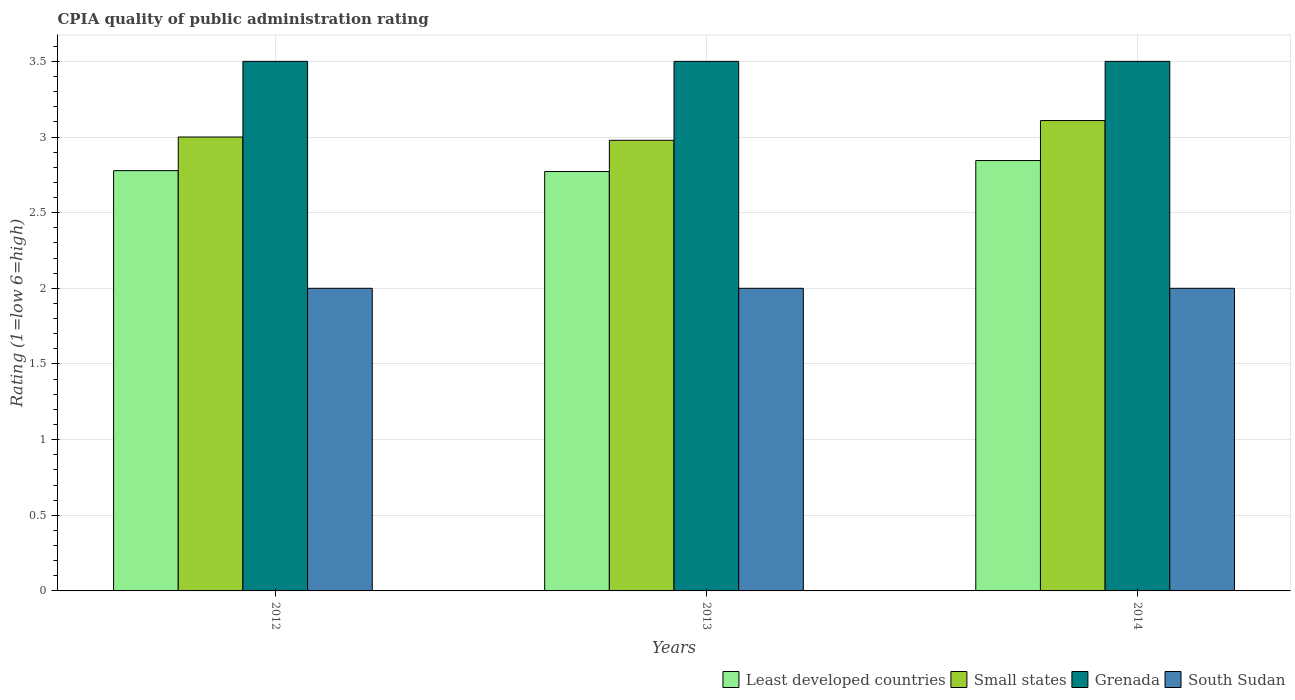How many different coloured bars are there?
Give a very brief answer. 4. How many groups of bars are there?
Offer a terse response. 3. Are the number of bars on each tick of the X-axis equal?
Your response must be concise. Yes. How many bars are there on the 3rd tick from the left?
Offer a very short reply. 4. How many bars are there on the 3rd tick from the right?
Make the answer very short. 4. What is the label of the 3rd group of bars from the left?
Your answer should be compact. 2014. What is the CPIA rating in Least developed countries in 2013?
Offer a very short reply. 2.77. In which year was the CPIA rating in Small states maximum?
Offer a terse response. 2014. What is the total CPIA rating in Least developed countries in the graph?
Offer a very short reply. 8.39. What is the difference between the CPIA rating in South Sudan in 2012 and that in 2014?
Your answer should be very brief. 0. What is the difference between the CPIA rating in Small states in 2014 and the CPIA rating in Grenada in 2013?
Provide a short and direct response. -0.39. What is the average CPIA rating in Least developed countries per year?
Provide a succinct answer. 2.8. In the year 2012, what is the difference between the CPIA rating in Least developed countries and CPIA rating in Grenada?
Offer a very short reply. -0.72. In how many years, is the CPIA rating in Grenada greater than 0.1?
Your response must be concise. 3. What is the ratio of the CPIA rating in South Sudan in 2012 to that in 2013?
Offer a terse response. 1. Is the difference between the CPIA rating in Least developed countries in 2012 and 2013 greater than the difference between the CPIA rating in Grenada in 2012 and 2013?
Your answer should be compact. Yes. What is the difference between the highest and the second highest CPIA rating in South Sudan?
Offer a very short reply. 0. What is the difference between the highest and the lowest CPIA rating in Small states?
Provide a short and direct response. 0.13. In how many years, is the CPIA rating in South Sudan greater than the average CPIA rating in South Sudan taken over all years?
Your response must be concise. 0. What does the 3rd bar from the left in 2014 represents?
Your response must be concise. Grenada. What does the 3rd bar from the right in 2013 represents?
Give a very brief answer. Small states. How many bars are there?
Provide a succinct answer. 12. Does the graph contain any zero values?
Give a very brief answer. No. Where does the legend appear in the graph?
Your response must be concise. Bottom right. How are the legend labels stacked?
Provide a short and direct response. Horizontal. What is the title of the graph?
Your response must be concise. CPIA quality of public administration rating. Does "Sudan" appear as one of the legend labels in the graph?
Keep it short and to the point. No. What is the label or title of the X-axis?
Provide a succinct answer. Years. What is the label or title of the Y-axis?
Give a very brief answer. Rating (1=low 6=high). What is the Rating (1=low 6=high) in Least developed countries in 2012?
Your answer should be compact. 2.78. What is the Rating (1=low 6=high) in South Sudan in 2012?
Your response must be concise. 2. What is the Rating (1=low 6=high) in Least developed countries in 2013?
Ensure brevity in your answer.  2.77. What is the Rating (1=low 6=high) of Small states in 2013?
Offer a terse response. 2.98. What is the Rating (1=low 6=high) in Grenada in 2013?
Provide a succinct answer. 3.5. What is the Rating (1=low 6=high) in Least developed countries in 2014?
Your answer should be compact. 2.84. What is the Rating (1=low 6=high) of Small states in 2014?
Make the answer very short. 3.11. What is the Rating (1=low 6=high) in Grenada in 2014?
Your response must be concise. 3.5. Across all years, what is the maximum Rating (1=low 6=high) of Least developed countries?
Make the answer very short. 2.84. Across all years, what is the maximum Rating (1=low 6=high) in Small states?
Ensure brevity in your answer.  3.11. Across all years, what is the minimum Rating (1=low 6=high) of Least developed countries?
Ensure brevity in your answer.  2.77. Across all years, what is the minimum Rating (1=low 6=high) of Small states?
Make the answer very short. 2.98. Across all years, what is the minimum Rating (1=low 6=high) of Grenada?
Provide a short and direct response. 3.5. What is the total Rating (1=low 6=high) of Least developed countries in the graph?
Offer a terse response. 8.39. What is the total Rating (1=low 6=high) in Small states in the graph?
Provide a short and direct response. 9.09. What is the difference between the Rating (1=low 6=high) in Least developed countries in 2012 and that in 2013?
Provide a short and direct response. 0.01. What is the difference between the Rating (1=low 6=high) in Small states in 2012 and that in 2013?
Make the answer very short. 0.02. What is the difference between the Rating (1=low 6=high) of Least developed countries in 2012 and that in 2014?
Your answer should be very brief. -0.07. What is the difference between the Rating (1=low 6=high) of Small states in 2012 and that in 2014?
Offer a very short reply. -0.11. What is the difference between the Rating (1=low 6=high) in Least developed countries in 2013 and that in 2014?
Provide a short and direct response. -0.07. What is the difference between the Rating (1=low 6=high) in Small states in 2013 and that in 2014?
Keep it short and to the point. -0.13. What is the difference between the Rating (1=low 6=high) of South Sudan in 2013 and that in 2014?
Offer a very short reply. 0. What is the difference between the Rating (1=low 6=high) of Least developed countries in 2012 and the Rating (1=low 6=high) of Small states in 2013?
Your answer should be very brief. -0.2. What is the difference between the Rating (1=low 6=high) of Least developed countries in 2012 and the Rating (1=low 6=high) of Grenada in 2013?
Your answer should be compact. -0.72. What is the difference between the Rating (1=low 6=high) in Grenada in 2012 and the Rating (1=low 6=high) in South Sudan in 2013?
Give a very brief answer. 1.5. What is the difference between the Rating (1=low 6=high) of Least developed countries in 2012 and the Rating (1=low 6=high) of Small states in 2014?
Keep it short and to the point. -0.33. What is the difference between the Rating (1=low 6=high) in Least developed countries in 2012 and the Rating (1=low 6=high) in Grenada in 2014?
Ensure brevity in your answer.  -0.72. What is the difference between the Rating (1=low 6=high) of Small states in 2012 and the Rating (1=low 6=high) of South Sudan in 2014?
Your answer should be compact. 1. What is the difference between the Rating (1=low 6=high) in Grenada in 2012 and the Rating (1=low 6=high) in South Sudan in 2014?
Offer a terse response. 1.5. What is the difference between the Rating (1=low 6=high) of Least developed countries in 2013 and the Rating (1=low 6=high) of Small states in 2014?
Give a very brief answer. -0.34. What is the difference between the Rating (1=low 6=high) of Least developed countries in 2013 and the Rating (1=low 6=high) of Grenada in 2014?
Offer a very short reply. -0.73. What is the difference between the Rating (1=low 6=high) in Least developed countries in 2013 and the Rating (1=low 6=high) in South Sudan in 2014?
Your response must be concise. 0.77. What is the difference between the Rating (1=low 6=high) in Small states in 2013 and the Rating (1=low 6=high) in Grenada in 2014?
Offer a very short reply. -0.52. What is the difference between the Rating (1=low 6=high) in Small states in 2013 and the Rating (1=low 6=high) in South Sudan in 2014?
Give a very brief answer. 0.98. What is the average Rating (1=low 6=high) in Least developed countries per year?
Ensure brevity in your answer.  2.8. What is the average Rating (1=low 6=high) of Small states per year?
Offer a very short reply. 3.03. In the year 2012, what is the difference between the Rating (1=low 6=high) in Least developed countries and Rating (1=low 6=high) in Small states?
Offer a terse response. -0.22. In the year 2012, what is the difference between the Rating (1=low 6=high) of Least developed countries and Rating (1=low 6=high) of Grenada?
Provide a succinct answer. -0.72. In the year 2012, what is the difference between the Rating (1=low 6=high) in Grenada and Rating (1=low 6=high) in South Sudan?
Your answer should be very brief. 1.5. In the year 2013, what is the difference between the Rating (1=low 6=high) of Least developed countries and Rating (1=low 6=high) of Small states?
Provide a short and direct response. -0.21. In the year 2013, what is the difference between the Rating (1=low 6=high) of Least developed countries and Rating (1=low 6=high) of Grenada?
Your answer should be compact. -0.73. In the year 2013, what is the difference between the Rating (1=low 6=high) in Least developed countries and Rating (1=low 6=high) in South Sudan?
Offer a terse response. 0.77. In the year 2013, what is the difference between the Rating (1=low 6=high) of Small states and Rating (1=low 6=high) of Grenada?
Keep it short and to the point. -0.52. In the year 2013, what is the difference between the Rating (1=low 6=high) of Small states and Rating (1=low 6=high) of South Sudan?
Your response must be concise. 0.98. In the year 2013, what is the difference between the Rating (1=low 6=high) in Grenada and Rating (1=low 6=high) in South Sudan?
Offer a terse response. 1.5. In the year 2014, what is the difference between the Rating (1=low 6=high) of Least developed countries and Rating (1=low 6=high) of Small states?
Your answer should be very brief. -0.26. In the year 2014, what is the difference between the Rating (1=low 6=high) of Least developed countries and Rating (1=low 6=high) of Grenada?
Give a very brief answer. -0.66. In the year 2014, what is the difference between the Rating (1=low 6=high) of Least developed countries and Rating (1=low 6=high) of South Sudan?
Your response must be concise. 0.84. In the year 2014, what is the difference between the Rating (1=low 6=high) in Small states and Rating (1=low 6=high) in Grenada?
Make the answer very short. -0.39. In the year 2014, what is the difference between the Rating (1=low 6=high) in Small states and Rating (1=low 6=high) in South Sudan?
Your response must be concise. 1.11. In the year 2014, what is the difference between the Rating (1=low 6=high) of Grenada and Rating (1=low 6=high) of South Sudan?
Your answer should be compact. 1.5. What is the ratio of the Rating (1=low 6=high) of Least developed countries in 2012 to that in 2013?
Keep it short and to the point. 1. What is the ratio of the Rating (1=low 6=high) of Small states in 2012 to that in 2013?
Provide a short and direct response. 1.01. What is the ratio of the Rating (1=low 6=high) in Grenada in 2012 to that in 2013?
Make the answer very short. 1. What is the ratio of the Rating (1=low 6=high) in South Sudan in 2012 to that in 2013?
Offer a very short reply. 1. What is the ratio of the Rating (1=low 6=high) in Least developed countries in 2012 to that in 2014?
Keep it short and to the point. 0.98. What is the ratio of the Rating (1=low 6=high) of South Sudan in 2012 to that in 2014?
Offer a terse response. 1. What is the ratio of the Rating (1=low 6=high) of Least developed countries in 2013 to that in 2014?
Your answer should be very brief. 0.97. What is the ratio of the Rating (1=low 6=high) of Small states in 2013 to that in 2014?
Ensure brevity in your answer.  0.96. What is the ratio of the Rating (1=low 6=high) of South Sudan in 2013 to that in 2014?
Your answer should be compact. 1. What is the difference between the highest and the second highest Rating (1=low 6=high) in Least developed countries?
Give a very brief answer. 0.07. What is the difference between the highest and the second highest Rating (1=low 6=high) in Small states?
Your answer should be compact. 0.11. What is the difference between the highest and the second highest Rating (1=low 6=high) in Grenada?
Your answer should be compact. 0. What is the difference between the highest and the lowest Rating (1=low 6=high) in Least developed countries?
Offer a terse response. 0.07. What is the difference between the highest and the lowest Rating (1=low 6=high) in Small states?
Provide a short and direct response. 0.13. What is the difference between the highest and the lowest Rating (1=low 6=high) of Grenada?
Your answer should be very brief. 0. What is the difference between the highest and the lowest Rating (1=low 6=high) in South Sudan?
Provide a short and direct response. 0. 